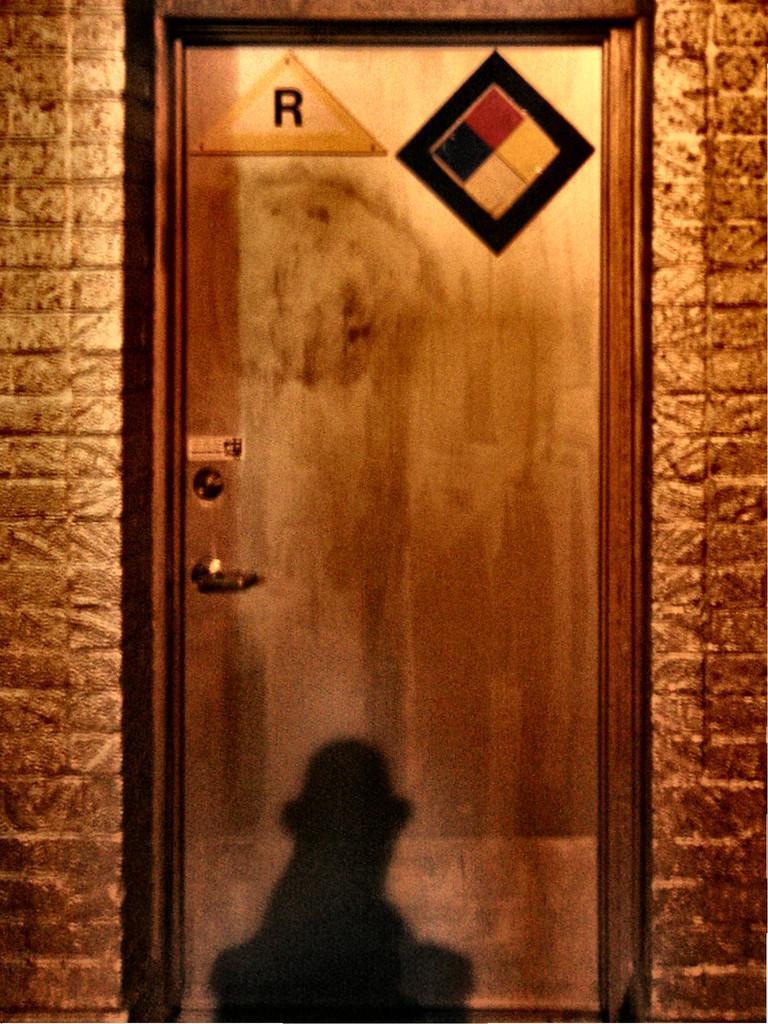In one or two sentences, can you explain what this image depicts? In the image we can see a door and a wall. On the door, we can see the reflection. 